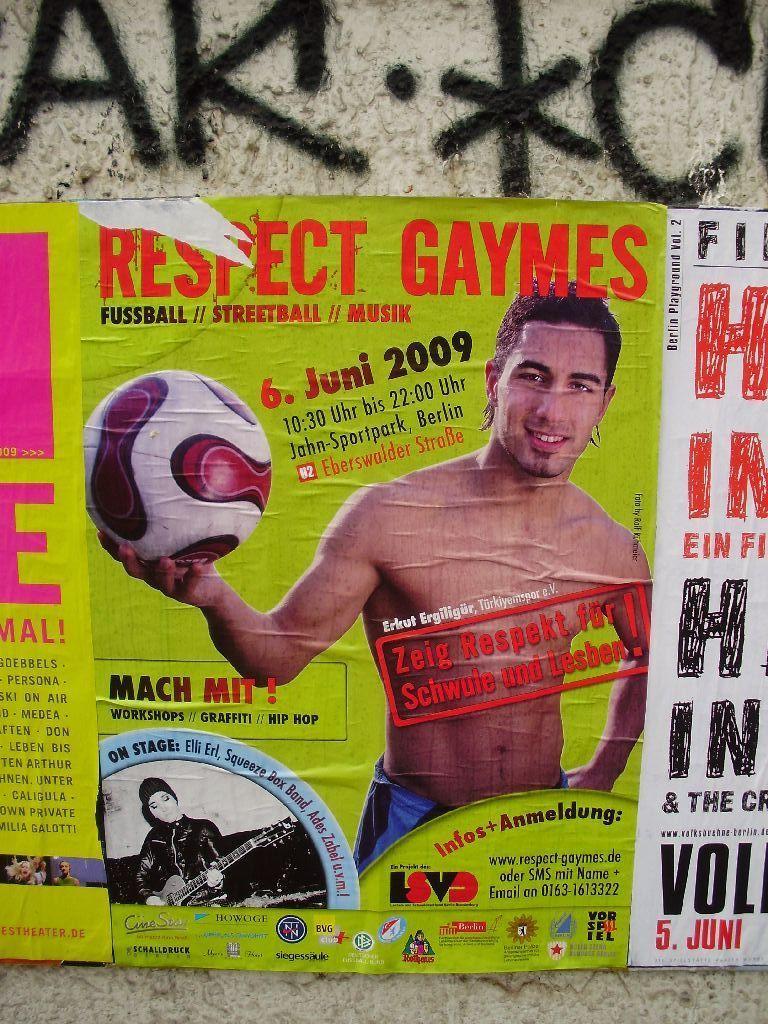Could you give a brief overview of what you see in this image? In a center of the picture there is a poster, in the poster there is a person holding a ball. At the bottom there is a person playing guitar. In the poster there is text. At the top there is text. 